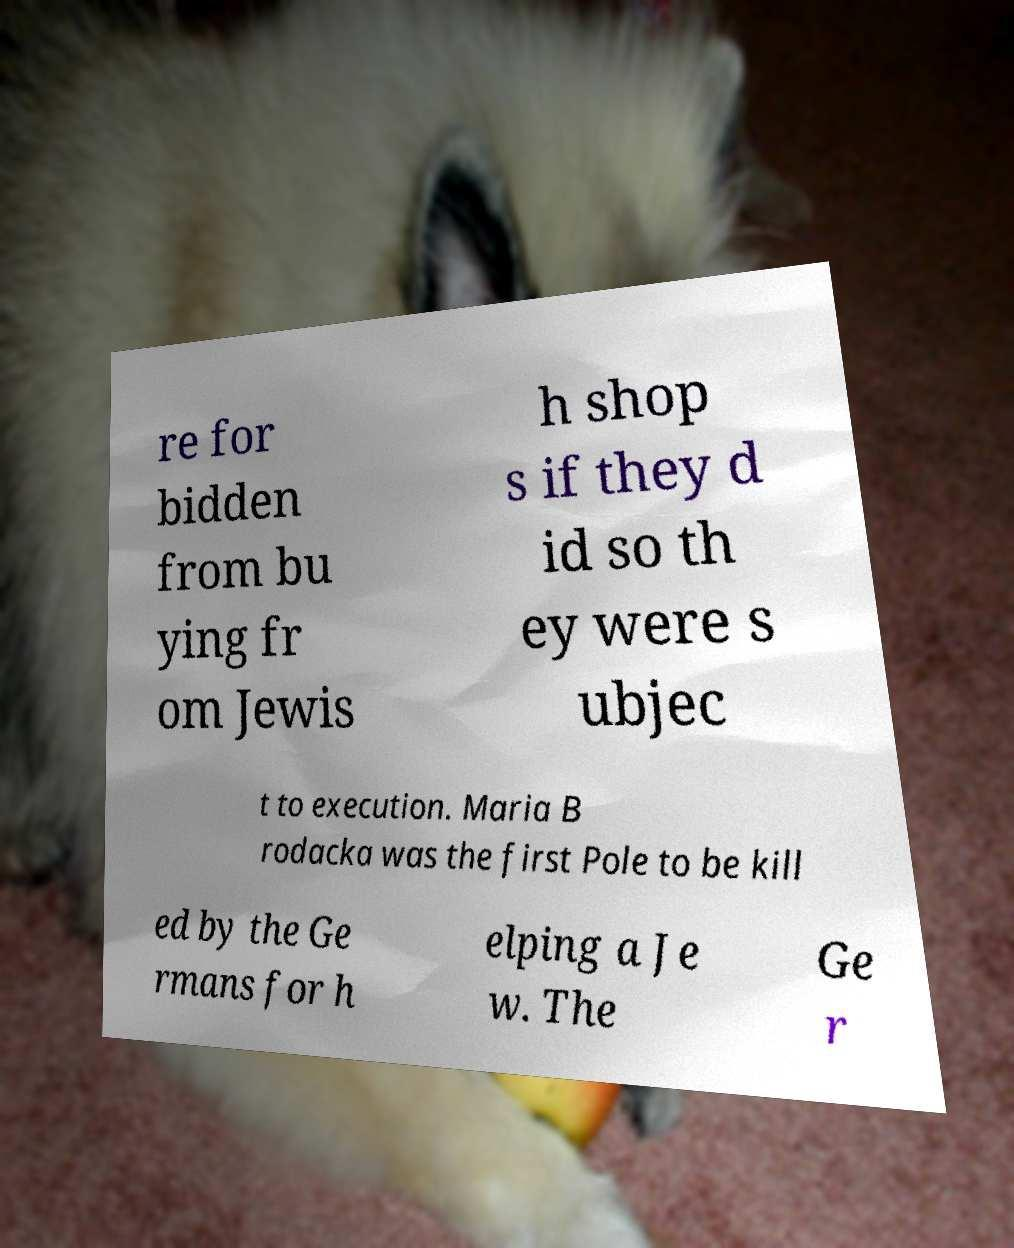Could you assist in decoding the text presented in this image and type it out clearly? re for bidden from bu ying fr om Jewis h shop s if they d id so th ey were s ubjec t to execution. Maria B rodacka was the first Pole to be kill ed by the Ge rmans for h elping a Je w. The Ge r 